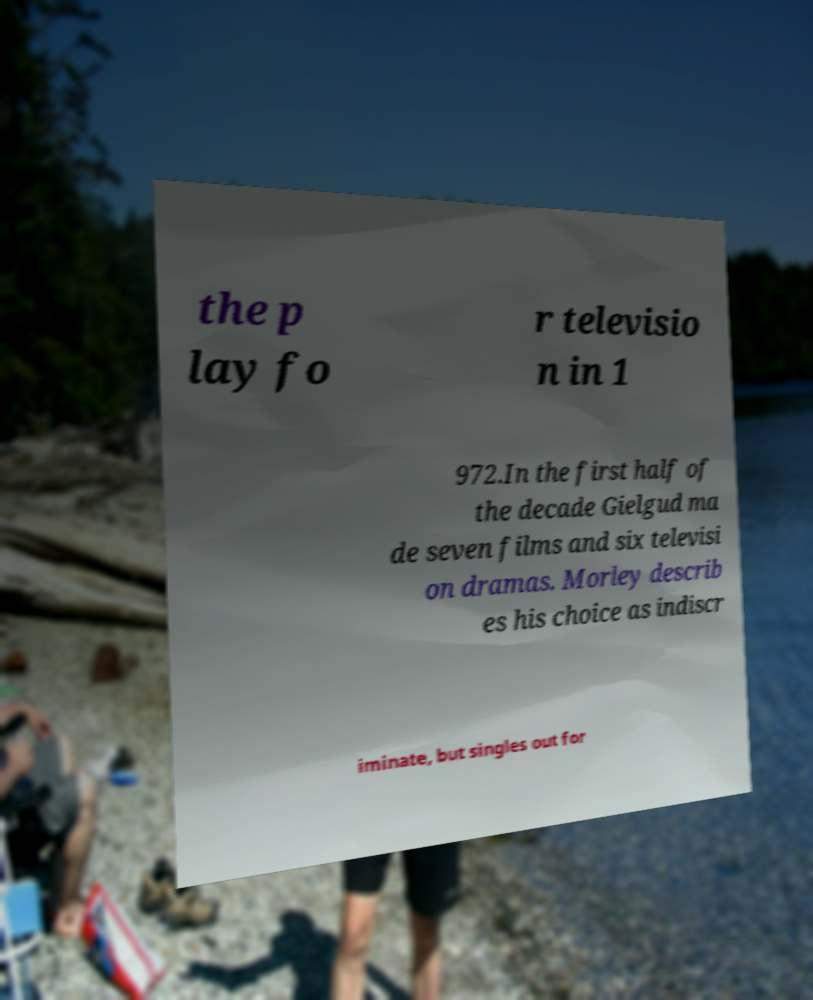Please read and relay the text visible in this image. What does it say? the p lay fo r televisio n in 1 972.In the first half of the decade Gielgud ma de seven films and six televisi on dramas. Morley describ es his choice as indiscr iminate, but singles out for 